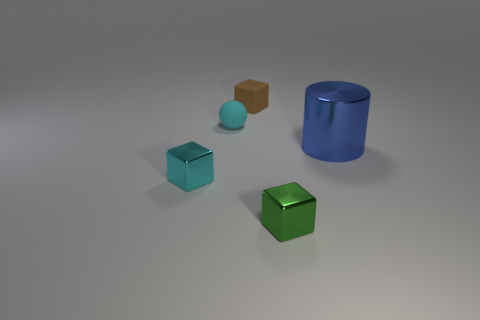Imagine these objects were part of a simple physics puzzle, how might they interact? If this were a physics puzzle, one might have to move the objects to achieve a specific goal. For example, the large green cube might act as a heavy object that needs to be moved onto a pressure plate. The smaller brown and cyan cubes could be stackable to create a makeshift staircase, and the cyan sphere might be able to roll into a designated area or trigger. As for the blue cylinder, it could perhaps fit into a vertical slot or be rolled to a certain location to open a path forward or activate a mechanism. 